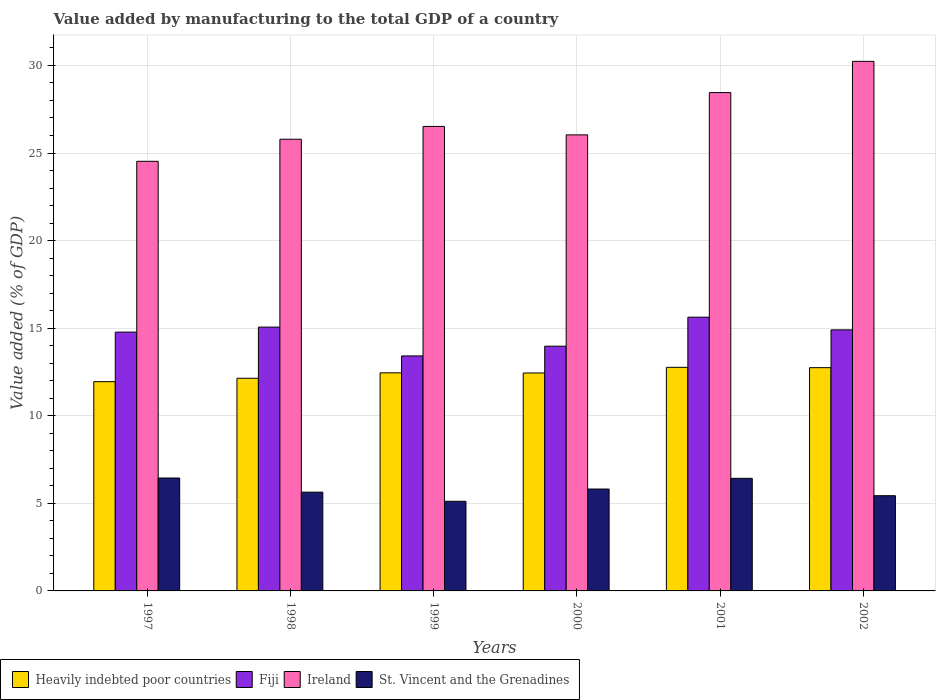How many groups of bars are there?
Keep it short and to the point. 6. Are the number of bars per tick equal to the number of legend labels?
Make the answer very short. Yes. Are the number of bars on each tick of the X-axis equal?
Provide a succinct answer. Yes. How many bars are there on the 1st tick from the right?
Make the answer very short. 4. What is the value added by manufacturing to the total GDP in Ireland in 1999?
Make the answer very short. 26.52. Across all years, what is the maximum value added by manufacturing to the total GDP in Heavily indebted poor countries?
Give a very brief answer. 12.76. Across all years, what is the minimum value added by manufacturing to the total GDP in Heavily indebted poor countries?
Your answer should be very brief. 11.95. In which year was the value added by manufacturing to the total GDP in Fiji maximum?
Your response must be concise. 2001. What is the total value added by manufacturing to the total GDP in Ireland in the graph?
Your answer should be compact. 161.55. What is the difference between the value added by manufacturing to the total GDP in Heavily indebted poor countries in 1997 and that in 1999?
Ensure brevity in your answer.  -0.5. What is the difference between the value added by manufacturing to the total GDP in Ireland in 2000 and the value added by manufacturing to the total GDP in Heavily indebted poor countries in 1998?
Make the answer very short. 13.9. What is the average value added by manufacturing to the total GDP in Heavily indebted poor countries per year?
Your answer should be very brief. 12.41. In the year 2002, what is the difference between the value added by manufacturing to the total GDP in Fiji and value added by manufacturing to the total GDP in Ireland?
Your answer should be compact. -15.33. What is the ratio of the value added by manufacturing to the total GDP in Fiji in 1998 to that in 1999?
Offer a terse response. 1.12. Is the value added by manufacturing to the total GDP in Ireland in 1997 less than that in 2001?
Ensure brevity in your answer.  Yes. What is the difference between the highest and the second highest value added by manufacturing to the total GDP in Ireland?
Provide a short and direct response. 1.78. What is the difference between the highest and the lowest value added by manufacturing to the total GDP in Heavily indebted poor countries?
Offer a terse response. 0.82. Is the sum of the value added by manufacturing to the total GDP in Ireland in 1999 and 2000 greater than the maximum value added by manufacturing to the total GDP in Heavily indebted poor countries across all years?
Ensure brevity in your answer.  Yes. What does the 1st bar from the left in 2000 represents?
Provide a succinct answer. Heavily indebted poor countries. What does the 1st bar from the right in 1999 represents?
Your answer should be compact. St. Vincent and the Grenadines. Is it the case that in every year, the sum of the value added by manufacturing to the total GDP in Heavily indebted poor countries and value added by manufacturing to the total GDP in St. Vincent and the Grenadines is greater than the value added by manufacturing to the total GDP in Ireland?
Your answer should be compact. No. Are the values on the major ticks of Y-axis written in scientific E-notation?
Offer a very short reply. No. Does the graph contain grids?
Provide a short and direct response. Yes. How are the legend labels stacked?
Offer a terse response. Horizontal. What is the title of the graph?
Make the answer very short. Value added by manufacturing to the total GDP of a country. What is the label or title of the X-axis?
Your answer should be very brief. Years. What is the label or title of the Y-axis?
Offer a very short reply. Value added (% of GDP). What is the Value added (% of GDP) of Heavily indebted poor countries in 1997?
Offer a very short reply. 11.95. What is the Value added (% of GDP) of Fiji in 1997?
Your response must be concise. 14.77. What is the Value added (% of GDP) of Ireland in 1997?
Make the answer very short. 24.53. What is the Value added (% of GDP) of St. Vincent and the Grenadines in 1997?
Offer a terse response. 6.45. What is the Value added (% of GDP) in Heavily indebted poor countries in 1998?
Offer a very short reply. 12.14. What is the Value added (% of GDP) in Fiji in 1998?
Ensure brevity in your answer.  15.06. What is the Value added (% of GDP) in Ireland in 1998?
Offer a very short reply. 25.79. What is the Value added (% of GDP) of St. Vincent and the Grenadines in 1998?
Keep it short and to the point. 5.64. What is the Value added (% of GDP) in Heavily indebted poor countries in 1999?
Offer a terse response. 12.45. What is the Value added (% of GDP) of Fiji in 1999?
Your response must be concise. 13.42. What is the Value added (% of GDP) of Ireland in 1999?
Your answer should be compact. 26.52. What is the Value added (% of GDP) in St. Vincent and the Grenadines in 1999?
Offer a terse response. 5.12. What is the Value added (% of GDP) of Heavily indebted poor countries in 2000?
Your answer should be very brief. 12.44. What is the Value added (% of GDP) of Fiji in 2000?
Offer a very short reply. 13.97. What is the Value added (% of GDP) in Ireland in 2000?
Your answer should be very brief. 26.04. What is the Value added (% of GDP) of St. Vincent and the Grenadines in 2000?
Keep it short and to the point. 5.82. What is the Value added (% of GDP) in Heavily indebted poor countries in 2001?
Provide a short and direct response. 12.76. What is the Value added (% of GDP) in Fiji in 2001?
Keep it short and to the point. 15.63. What is the Value added (% of GDP) in Ireland in 2001?
Offer a very short reply. 28.45. What is the Value added (% of GDP) in St. Vincent and the Grenadines in 2001?
Your answer should be compact. 6.43. What is the Value added (% of GDP) in Heavily indebted poor countries in 2002?
Your answer should be very brief. 12.75. What is the Value added (% of GDP) in Fiji in 2002?
Provide a succinct answer. 14.9. What is the Value added (% of GDP) in Ireland in 2002?
Your answer should be compact. 30.23. What is the Value added (% of GDP) in St. Vincent and the Grenadines in 2002?
Keep it short and to the point. 5.44. Across all years, what is the maximum Value added (% of GDP) in Heavily indebted poor countries?
Keep it short and to the point. 12.76. Across all years, what is the maximum Value added (% of GDP) in Fiji?
Your response must be concise. 15.63. Across all years, what is the maximum Value added (% of GDP) in Ireland?
Ensure brevity in your answer.  30.23. Across all years, what is the maximum Value added (% of GDP) in St. Vincent and the Grenadines?
Your response must be concise. 6.45. Across all years, what is the minimum Value added (% of GDP) in Heavily indebted poor countries?
Offer a very short reply. 11.95. Across all years, what is the minimum Value added (% of GDP) in Fiji?
Keep it short and to the point. 13.42. Across all years, what is the minimum Value added (% of GDP) of Ireland?
Ensure brevity in your answer.  24.53. Across all years, what is the minimum Value added (% of GDP) in St. Vincent and the Grenadines?
Your answer should be compact. 5.12. What is the total Value added (% of GDP) in Heavily indebted poor countries in the graph?
Keep it short and to the point. 74.49. What is the total Value added (% of GDP) of Fiji in the graph?
Your answer should be compact. 87.75. What is the total Value added (% of GDP) of Ireland in the graph?
Offer a very short reply. 161.55. What is the total Value added (% of GDP) of St. Vincent and the Grenadines in the graph?
Ensure brevity in your answer.  34.88. What is the difference between the Value added (% of GDP) of Heavily indebted poor countries in 1997 and that in 1998?
Your answer should be compact. -0.19. What is the difference between the Value added (% of GDP) in Fiji in 1997 and that in 1998?
Keep it short and to the point. -0.29. What is the difference between the Value added (% of GDP) in Ireland in 1997 and that in 1998?
Make the answer very short. -1.26. What is the difference between the Value added (% of GDP) of St. Vincent and the Grenadines in 1997 and that in 1998?
Ensure brevity in your answer.  0.81. What is the difference between the Value added (% of GDP) of Heavily indebted poor countries in 1997 and that in 1999?
Your answer should be compact. -0.5. What is the difference between the Value added (% of GDP) in Fiji in 1997 and that in 1999?
Provide a succinct answer. 1.36. What is the difference between the Value added (% of GDP) in Ireland in 1997 and that in 1999?
Offer a terse response. -1.99. What is the difference between the Value added (% of GDP) in St. Vincent and the Grenadines in 1997 and that in 1999?
Provide a short and direct response. 1.33. What is the difference between the Value added (% of GDP) of Heavily indebted poor countries in 1997 and that in 2000?
Your response must be concise. -0.49. What is the difference between the Value added (% of GDP) in Fiji in 1997 and that in 2000?
Ensure brevity in your answer.  0.8. What is the difference between the Value added (% of GDP) in Ireland in 1997 and that in 2000?
Offer a terse response. -1.51. What is the difference between the Value added (% of GDP) of St. Vincent and the Grenadines in 1997 and that in 2000?
Offer a terse response. 0.63. What is the difference between the Value added (% of GDP) of Heavily indebted poor countries in 1997 and that in 2001?
Give a very brief answer. -0.82. What is the difference between the Value added (% of GDP) in Fiji in 1997 and that in 2001?
Keep it short and to the point. -0.85. What is the difference between the Value added (% of GDP) in Ireland in 1997 and that in 2001?
Keep it short and to the point. -3.92. What is the difference between the Value added (% of GDP) in St. Vincent and the Grenadines in 1997 and that in 2001?
Your answer should be compact. 0.02. What is the difference between the Value added (% of GDP) in Heavily indebted poor countries in 1997 and that in 2002?
Provide a succinct answer. -0.8. What is the difference between the Value added (% of GDP) of Fiji in 1997 and that in 2002?
Your answer should be very brief. -0.13. What is the difference between the Value added (% of GDP) of Ireland in 1997 and that in 2002?
Make the answer very short. -5.71. What is the difference between the Value added (% of GDP) of St. Vincent and the Grenadines in 1997 and that in 2002?
Keep it short and to the point. 1.01. What is the difference between the Value added (% of GDP) in Heavily indebted poor countries in 1998 and that in 1999?
Ensure brevity in your answer.  -0.31. What is the difference between the Value added (% of GDP) of Fiji in 1998 and that in 1999?
Offer a terse response. 1.65. What is the difference between the Value added (% of GDP) in Ireland in 1998 and that in 1999?
Offer a very short reply. -0.73. What is the difference between the Value added (% of GDP) of St. Vincent and the Grenadines in 1998 and that in 1999?
Your answer should be very brief. 0.52. What is the difference between the Value added (% of GDP) of Heavily indebted poor countries in 1998 and that in 2000?
Offer a terse response. -0.3. What is the difference between the Value added (% of GDP) of Fiji in 1998 and that in 2000?
Offer a terse response. 1.09. What is the difference between the Value added (% of GDP) in Ireland in 1998 and that in 2000?
Give a very brief answer. -0.25. What is the difference between the Value added (% of GDP) of St. Vincent and the Grenadines in 1998 and that in 2000?
Your answer should be compact. -0.18. What is the difference between the Value added (% of GDP) in Heavily indebted poor countries in 1998 and that in 2001?
Provide a succinct answer. -0.62. What is the difference between the Value added (% of GDP) of Fiji in 1998 and that in 2001?
Your answer should be compact. -0.57. What is the difference between the Value added (% of GDP) of Ireland in 1998 and that in 2001?
Keep it short and to the point. -2.66. What is the difference between the Value added (% of GDP) of St. Vincent and the Grenadines in 1998 and that in 2001?
Provide a short and direct response. -0.79. What is the difference between the Value added (% of GDP) in Heavily indebted poor countries in 1998 and that in 2002?
Keep it short and to the point. -0.6. What is the difference between the Value added (% of GDP) in Fiji in 1998 and that in 2002?
Keep it short and to the point. 0.16. What is the difference between the Value added (% of GDP) of Ireland in 1998 and that in 2002?
Provide a succinct answer. -4.45. What is the difference between the Value added (% of GDP) in St. Vincent and the Grenadines in 1998 and that in 2002?
Make the answer very short. 0.2. What is the difference between the Value added (% of GDP) of Heavily indebted poor countries in 1999 and that in 2000?
Make the answer very short. 0.01. What is the difference between the Value added (% of GDP) in Fiji in 1999 and that in 2000?
Provide a succinct answer. -0.56. What is the difference between the Value added (% of GDP) in Ireland in 1999 and that in 2000?
Your answer should be compact. 0.48. What is the difference between the Value added (% of GDP) in St. Vincent and the Grenadines in 1999 and that in 2000?
Offer a terse response. -0.7. What is the difference between the Value added (% of GDP) in Heavily indebted poor countries in 1999 and that in 2001?
Provide a short and direct response. -0.31. What is the difference between the Value added (% of GDP) of Fiji in 1999 and that in 2001?
Your answer should be compact. -2.21. What is the difference between the Value added (% of GDP) of Ireland in 1999 and that in 2001?
Ensure brevity in your answer.  -1.93. What is the difference between the Value added (% of GDP) of St. Vincent and the Grenadines in 1999 and that in 2001?
Offer a terse response. -1.31. What is the difference between the Value added (% of GDP) of Heavily indebted poor countries in 1999 and that in 2002?
Your answer should be very brief. -0.29. What is the difference between the Value added (% of GDP) of Fiji in 1999 and that in 2002?
Offer a terse response. -1.49. What is the difference between the Value added (% of GDP) in Ireland in 1999 and that in 2002?
Make the answer very short. -3.72. What is the difference between the Value added (% of GDP) in St. Vincent and the Grenadines in 1999 and that in 2002?
Offer a very short reply. -0.32. What is the difference between the Value added (% of GDP) of Heavily indebted poor countries in 2000 and that in 2001?
Keep it short and to the point. -0.32. What is the difference between the Value added (% of GDP) in Fiji in 2000 and that in 2001?
Ensure brevity in your answer.  -1.66. What is the difference between the Value added (% of GDP) of Ireland in 2000 and that in 2001?
Give a very brief answer. -2.41. What is the difference between the Value added (% of GDP) in St. Vincent and the Grenadines in 2000 and that in 2001?
Ensure brevity in your answer.  -0.61. What is the difference between the Value added (% of GDP) in Heavily indebted poor countries in 2000 and that in 2002?
Provide a succinct answer. -0.3. What is the difference between the Value added (% of GDP) of Fiji in 2000 and that in 2002?
Offer a terse response. -0.93. What is the difference between the Value added (% of GDP) of Ireland in 2000 and that in 2002?
Provide a short and direct response. -4.2. What is the difference between the Value added (% of GDP) of St. Vincent and the Grenadines in 2000 and that in 2002?
Your answer should be compact. 0.38. What is the difference between the Value added (% of GDP) in Heavily indebted poor countries in 2001 and that in 2002?
Your response must be concise. 0.02. What is the difference between the Value added (% of GDP) in Fiji in 2001 and that in 2002?
Keep it short and to the point. 0.72. What is the difference between the Value added (% of GDP) in Ireland in 2001 and that in 2002?
Give a very brief answer. -1.78. What is the difference between the Value added (% of GDP) of Heavily indebted poor countries in 1997 and the Value added (% of GDP) of Fiji in 1998?
Make the answer very short. -3.12. What is the difference between the Value added (% of GDP) of Heavily indebted poor countries in 1997 and the Value added (% of GDP) of Ireland in 1998?
Keep it short and to the point. -13.84. What is the difference between the Value added (% of GDP) in Heavily indebted poor countries in 1997 and the Value added (% of GDP) in St. Vincent and the Grenadines in 1998?
Provide a succinct answer. 6.31. What is the difference between the Value added (% of GDP) of Fiji in 1997 and the Value added (% of GDP) of Ireland in 1998?
Provide a succinct answer. -11.01. What is the difference between the Value added (% of GDP) in Fiji in 1997 and the Value added (% of GDP) in St. Vincent and the Grenadines in 1998?
Make the answer very short. 9.14. What is the difference between the Value added (% of GDP) in Ireland in 1997 and the Value added (% of GDP) in St. Vincent and the Grenadines in 1998?
Ensure brevity in your answer.  18.89. What is the difference between the Value added (% of GDP) of Heavily indebted poor countries in 1997 and the Value added (% of GDP) of Fiji in 1999?
Provide a succinct answer. -1.47. What is the difference between the Value added (% of GDP) in Heavily indebted poor countries in 1997 and the Value added (% of GDP) in Ireland in 1999?
Provide a succinct answer. -14.57. What is the difference between the Value added (% of GDP) in Heavily indebted poor countries in 1997 and the Value added (% of GDP) in St. Vincent and the Grenadines in 1999?
Keep it short and to the point. 6.83. What is the difference between the Value added (% of GDP) in Fiji in 1997 and the Value added (% of GDP) in Ireland in 1999?
Your answer should be compact. -11.74. What is the difference between the Value added (% of GDP) in Fiji in 1997 and the Value added (% of GDP) in St. Vincent and the Grenadines in 1999?
Provide a succinct answer. 9.66. What is the difference between the Value added (% of GDP) in Ireland in 1997 and the Value added (% of GDP) in St. Vincent and the Grenadines in 1999?
Provide a short and direct response. 19.41. What is the difference between the Value added (% of GDP) of Heavily indebted poor countries in 1997 and the Value added (% of GDP) of Fiji in 2000?
Keep it short and to the point. -2.02. What is the difference between the Value added (% of GDP) in Heavily indebted poor countries in 1997 and the Value added (% of GDP) in Ireland in 2000?
Provide a short and direct response. -14.09. What is the difference between the Value added (% of GDP) in Heavily indebted poor countries in 1997 and the Value added (% of GDP) in St. Vincent and the Grenadines in 2000?
Offer a terse response. 6.13. What is the difference between the Value added (% of GDP) of Fiji in 1997 and the Value added (% of GDP) of Ireland in 2000?
Offer a very short reply. -11.26. What is the difference between the Value added (% of GDP) of Fiji in 1997 and the Value added (% of GDP) of St. Vincent and the Grenadines in 2000?
Provide a succinct answer. 8.96. What is the difference between the Value added (% of GDP) in Ireland in 1997 and the Value added (% of GDP) in St. Vincent and the Grenadines in 2000?
Your answer should be very brief. 18.71. What is the difference between the Value added (% of GDP) of Heavily indebted poor countries in 1997 and the Value added (% of GDP) of Fiji in 2001?
Provide a short and direct response. -3.68. What is the difference between the Value added (% of GDP) of Heavily indebted poor countries in 1997 and the Value added (% of GDP) of Ireland in 2001?
Your response must be concise. -16.5. What is the difference between the Value added (% of GDP) in Heavily indebted poor countries in 1997 and the Value added (% of GDP) in St. Vincent and the Grenadines in 2001?
Provide a succinct answer. 5.52. What is the difference between the Value added (% of GDP) in Fiji in 1997 and the Value added (% of GDP) in Ireland in 2001?
Ensure brevity in your answer.  -13.67. What is the difference between the Value added (% of GDP) of Fiji in 1997 and the Value added (% of GDP) of St. Vincent and the Grenadines in 2001?
Your answer should be very brief. 8.35. What is the difference between the Value added (% of GDP) in Ireland in 1997 and the Value added (% of GDP) in St. Vincent and the Grenadines in 2001?
Offer a terse response. 18.1. What is the difference between the Value added (% of GDP) in Heavily indebted poor countries in 1997 and the Value added (% of GDP) in Fiji in 2002?
Provide a short and direct response. -2.96. What is the difference between the Value added (% of GDP) of Heavily indebted poor countries in 1997 and the Value added (% of GDP) of Ireland in 2002?
Provide a short and direct response. -18.29. What is the difference between the Value added (% of GDP) of Heavily indebted poor countries in 1997 and the Value added (% of GDP) of St. Vincent and the Grenadines in 2002?
Your response must be concise. 6.51. What is the difference between the Value added (% of GDP) in Fiji in 1997 and the Value added (% of GDP) in Ireland in 2002?
Provide a succinct answer. -15.46. What is the difference between the Value added (% of GDP) in Fiji in 1997 and the Value added (% of GDP) in St. Vincent and the Grenadines in 2002?
Keep it short and to the point. 9.34. What is the difference between the Value added (% of GDP) of Ireland in 1997 and the Value added (% of GDP) of St. Vincent and the Grenadines in 2002?
Make the answer very short. 19.09. What is the difference between the Value added (% of GDP) of Heavily indebted poor countries in 1998 and the Value added (% of GDP) of Fiji in 1999?
Offer a very short reply. -1.27. What is the difference between the Value added (% of GDP) of Heavily indebted poor countries in 1998 and the Value added (% of GDP) of Ireland in 1999?
Give a very brief answer. -14.38. What is the difference between the Value added (% of GDP) in Heavily indebted poor countries in 1998 and the Value added (% of GDP) in St. Vincent and the Grenadines in 1999?
Your answer should be compact. 7.02. What is the difference between the Value added (% of GDP) of Fiji in 1998 and the Value added (% of GDP) of Ireland in 1999?
Provide a short and direct response. -11.46. What is the difference between the Value added (% of GDP) of Fiji in 1998 and the Value added (% of GDP) of St. Vincent and the Grenadines in 1999?
Provide a short and direct response. 9.94. What is the difference between the Value added (% of GDP) in Ireland in 1998 and the Value added (% of GDP) in St. Vincent and the Grenadines in 1999?
Keep it short and to the point. 20.67. What is the difference between the Value added (% of GDP) in Heavily indebted poor countries in 1998 and the Value added (% of GDP) in Fiji in 2000?
Provide a succinct answer. -1.83. What is the difference between the Value added (% of GDP) in Heavily indebted poor countries in 1998 and the Value added (% of GDP) in Ireland in 2000?
Provide a short and direct response. -13.9. What is the difference between the Value added (% of GDP) of Heavily indebted poor countries in 1998 and the Value added (% of GDP) of St. Vincent and the Grenadines in 2000?
Your answer should be compact. 6.32. What is the difference between the Value added (% of GDP) in Fiji in 1998 and the Value added (% of GDP) in Ireland in 2000?
Offer a very short reply. -10.97. What is the difference between the Value added (% of GDP) of Fiji in 1998 and the Value added (% of GDP) of St. Vincent and the Grenadines in 2000?
Make the answer very short. 9.24. What is the difference between the Value added (% of GDP) of Ireland in 1998 and the Value added (% of GDP) of St. Vincent and the Grenadines in 2000?
Offer a terse response. 19.97. What is the difference between the Value added (% of GDP) of Heavily indebted poor countries in 1998 and the Value added (% of GDP) of Fiji in 2001?
Provide a short and direct response. -3.49. What is the difference between the Value added (% of GDP) in Heavily indebted poor countries in 1998 and the Value added (% of GDP) in Ireland in 2001?
Keep it short and to the point. -16.31. What is the difference between the Value added (% of GDP) of Heavily indebted poor countries in 1998 and the Value added (% of GDP) of St. Vincent and the Grenadines in 2001?
Your response must be concise. 5.71. What is the difference between the Value added (% of GDP) in Fiji in 1998 and the Value added (% of GDP) in Ireland in 2001?
Give a very brief answer. -13.39. What is the difference between the Value added (% of GDP) in Fiji in 1998 and the Value added (% of GDP) in St. Vincent and the Grenadines in 2001?
Your answer should be compact. 8.63. What is the difference between the Value added (% of GDP) in Ireland in 1998 and the Value added (% of GDP) in St. Vincent and the Grenadines in 2001?
Offer a very short reply. 19.36. What is the difference between the Value added (% of GDP) of Heavily indebted poor countries in 1998 and the Value added (% of GDP) of Fiji in 2002?
Offer a very short reply. -2.76. What is the difference between the Value added (% of GDP) of Heavily indebted poor countries in 1998 and the Value added (% of GDP) of Ireland in 2002?
Your answer should be very brief. -18.09. What is the difference between the Value added (% of GDP) in Heavily indebted poor countries in 1998 and the Value added (% of GDP) in St. Vincent and the Grenadines in 2002?
Ensure brevity in your answer.  6.7. What is the difference between the Value added (% of GDP) in Fiji in 1998 and the Value added (% of GDP) in Ireland in 2002?
Your answer should be very brief. -15.17. What is the difference between the Value added (% of GDP) in Fiji in 1998 and the Value added (% of GDP) in St. Vincent and the Grenadines in 2002?
Your response must be concise. 9.63. What is the difference between the Value added (% of GDP) of Ireland in 1998 and the Value added (% of GDP) of St. Vincent and the Grenadines in 2002?
Your answer should be very brief. 20.35. What is the difference between the Value added (% of GDP) in Heavily indebted poor countries in 1999 and the Value added (% of GDP) in Fiji in 2000?
Your answer should be compact. -1.52. What is the difference between the Value added (% of GDP) of Heavily indebted poor countries in 1999 and the Value added (% of GDP) of Ireland in 2000?
Your answer should be very brief. -13.59. What is the difference between the Value added (% of GDP) of Heavily indebted poor countries in 1999 and the Value added (% of GDP) of St. Vincent and the Grenadines in 2000?
Keep it short and to the point. 6.63. What is the difference between the Value added (% of GDP) in Fiji in 1999 and the Value added (% of GDP) in Ireland in 2000?
Provide a succinct answer. -12.62. What is the difference between the Value added (% of GDP) of Fiji in 1999 and the Value added (% of GDP) of St. Vincent and the Grenadines in 2000?
Provide a short and direct response. 7.6. What is the difference between the Value added (% of GDP) of Ireland in 1999 and the Value added (% of GDP) of St. Vincent and the Grenadines in 2000?
Your answer should be very brief. 20.7. What is the difference between the Value added (% of GDP) in Heavily indebted poor countries in 1999 and the Value added (% of GDP) in Fiji in 2001?
Your answer should be very brief. -3.18. What is the difference between the Value added (% of GDP) in Heavily indebted poor countries in 1999 and the Value added (% of GDP) in Ireland in 2001?
Make the answer very short. -16. What is the difference between the Value added (% of GDP) in Heavily indebted poor countries in 1999 and the Value added (% of GDP) in St. Vincent and the Grenadines in 2001?
Make the answer very short. 6.02. What is the difference between the Value added (% of GDP) in Fiji in 1999 and the Value added (% of GDP) in Ireland in 2001?
Your answer should be compact. -15.03. What is the difference between the Value added (% of GDP) in Fiji in 1999 and the Value added (% of GDP) in St. Vincent and the Grenadines in 2001?
Keep it short and to the point. 6.99. What is the difference between the Value added (% of GDP) of Ireland in 1999 and the Value added (% of GDP) of St. Vincent and the Grenadines in 2001?
Your answer should be compact. 20.09. What is the difference between the Value added (% of GDP) in Heavily indebted poor countries in 1999 and the Value added (% of GDP) in Fiji in 2002?
Offer a terse response. -2.45. What is the difference between the Value added (% of GDP) of Heavily indebted poor countries in 1999 and the Value added (% of GDP) of Ireland in 2002?
Your response must be concise. -17.78. What is the difference between the Value added (% of GDP) in Heavily indebted poor countries in 1999 and the Value added (% of GDP) in St. Vincent and the Grenadines in 2002?
Keep it short and to the point. 7.01. What is the difference between the Value added (% of GDP) in Fiji in 1999 and the Value added (% of GDP) in Ireland in 2002?
Give a very brief answer. -16.82. What is the difference between the Value added (% of GDP) in Fiji in 1999 and the Value added (% of GDP) in St. Vincent and the Grenadines in 2002?
Give a very brief answer. 7.98. What is the difference between the Value added (% of GDP) in Ireland in 1999 and the Value added (% of GDP) in St. Vincent and the Grenadines in 2002?
Offer a terse response. 21.08. What is the difference between the Value added (% of GDP) of Heavily indebted poor countries in 2000 and the Value added (% of GDP) of Fiji in 2001?
Your answer should be very brief. -3.19. What is the difference between the Value added (% of GDP) of Heavily indebted poor countries in 2000 and the Value added (% of GDP) of Ireland in 2001?
Your response must be concise. -16.01. What is the difference between the Value added (% of GDP) of Heavily indebted poor countries in 2000 and the Value added (% of GDP) of St. Vincent and the Grenadines in 2001?
Offer a very short reply. 6.01. What is the difference between the Value added (% of GDP) of Fiji in 2000 and the Value added (% of GDP) of Ireland in 2001?
Ensure brevity in your answer.  -14.48. What is the difference between the Value added (% of GDP) in Fiji in 2000 and the Value added (% of GDP) in St. Vincent and the Grenadines in 2001?
Keep it short and to the point. 7.54. What is the difference between the Value added (% of GDP) of Ireland in 2000 and the Value added (% of GDP) of St. Vincent and the Grenadines in 2001?
Give a very brief answer. 19.61. What is the difference between the Value added (% of GDP) in Heavily indebted poor countries in 2000 and the Value added (% of GDP) in Fiji in 2002?
Give a very brief answer. -2.46. What is the difference between the Value added (% of GDP) in Heavily indebted poor countries in 2000 and the Value added (% of GDP) in Ireland in 2002?
Your response must be concise. -17.79. What is the difference between the Value added (% of GDP) in Heavily indebted poor countries in 2000 and the Value added (% of GDP) in St. Vincent and the Grenadines in 2002?
Keep it short and to the point. 7.01. What is the difference between the Value added (% of GDP) in Fiji in 2000 and the Value added (% of GDP) in Ireland in 2002?
Make the answer very short. -16.26. What is the difference between the Value added (% of GDP) in Fiji in 2000 and the Value added (% of GDP) in St. Vincent and the Grenadines in 2002?
Make the answer very short. 8.54. What is the difference between the Value added (% of GDP) of Ireland in 2000 and the Value added (% of GDP) of St. Vincent and the Grenadines in 2002?
Your response must be concise. 20.6. What is the difference between the Value added (% of GDP) in Heavily indebted poor countries in 2001 and the Value added (% of GDP) in Fiji in 2002?
Keep it short and to the point. -2.14. What is the difference between the Value added (% of GDP) in Heavily indebted poor countries in 2001 and the Value added (% of GDP) in Ireland in 2002?
Offer a terse response. -17.47. What is the difference between the Value added (% of GDP) of Heavily indebted poor countries in 2001 and the Value added (% of GDP) of St. Vincent and the Grenadines in 2002?
Offer a terse response. 7.33. What is the difference between the Value added (% of GDP) in Fiji in 2001 and the Value added (% of GDP) in Ireland in 2002?
Your response must be concise. -14.61. What is the difference between the Value added (% of GDP) of Fiji in 2001 and the Value added (% of GDP) of St. Vincent and the Grenadines in 2002?
Your answer should be very brief. 10.19. What is the difference between the Value added (% of GDP) of Ireland in 2001 and the Value added (% of GDP) of St. Vincent and the Grenadines in 2002?
Offer a very short reply. 23.01. What is the average Value added (% of GDP) of Heavily indebted poor countries per year?
Ensure brevity in your answer.  12.41. What is the average Value added (% of GDP) of Fiji per year?
Make the answer very short. 14.63. What is the average Value added (% of GDP) of Ireland per year?
Offer a terse response. 26.92. What is the average Value added (% of GDP) of St. Vincent and the Grenadines per year?
Offer a terse response. 5.81. In the year 1997, what is the difference between the Value added (% of GDP) in Heavily indebted poor countries and Value added (% of GDP) in Fiji?
Give a very brief answer. -2.83. In the year 1997, what is the difference between the Value added (% of GDP) of Heavily indebted poor countries and Value added (% of GDP) of Ireland?
Ensure brevity in your answer.  -12.58. In the year 1997, what is the difference between the Value added (% of GDP) in Heavily indebted poor countries and Value added (% of GDP) in St. Vincent and the Grenadines?
Keep it short and to the point. 5.5. In the year 1997, what is the difference between the Value added (% of GDP) of Fiji and Value added (% of GDP) of Ireland?
Offer a very short reply. -9.75. In the year 1997, what is the difference between the Value added (% of GDP) of Fiji and Value added (% of GDP) of St. Vincent and the Grenadines?
Provide a short and direct response. 8.33. In the year 1997, what is the difference between the Value added (% of GDP) in Ireland and Value added (% of GDP) in St. Vincent and the Grenadines?
Ensure brevity in your answer.  18.08. In the year 1998, what is the difference between the Value added (% of GDP) in Heavily indebted poor countries and Value added (% of GDP) in Fiji?
Provide a succinct answer. -2.92. In the year 1998, what is the difference between the Value added (% of GDP) in Heavily indebted poor countries and Value added (% of GDP) in Ireland?
Offer a terse response. -13.65. In the year 1998, what is the difference between the Value added (% of GDP) in Heavily indebted poor countries and Value added (% of GDP) in St. Vincent and the Grenadines?
Keep it short and to the point. 6.5. In the year 1998, what is the difference between the Value added (% of GDP) in Fiji and Value added (% of GDP) in Ireland?
Provide a short and direct response. -10.73. In the year 1998, what is the difference between the Value added (% of GDP) in Fiji and Value added (% of GDP) in St. Vincent and the Grenadines?
Provide a succinct answer. 9.42. In the year 1998, what is the difference between the Value added (% of GDP) in Ireland and Value added (% of GDP) in St. Vincent and the Grenadines?
Your response must be concise. 20.15. In the year 1999, what is the difference between the Value added (% of GDP) in Heavily indebted poor countries and Value added (% of GDP) in Fiji?
Offer a terse response. -0.96. In the year 1999, what is the difference between the Value added (% of GDP) of Heavily indebted poor countries and Value added (% of GDP) of Ireland?
Give a very brief answer. -14.07. In the year 1999, what is the difference between the Value added (% of GDP) in Heavily indebted poor countries and Value added (% of GDP) in St. Vincent and the Grenadines?
Provide a short and direct response. 7.33. In the year 1999, what is the difference between the Value added (% of GDP) of Fiji and Value added (% of GDP) of Ireland?
Provide a succinct answer. -13.1. In the year 1999, what is the difference between the Value added (% of GDP) in Fiji and Value added (% of GDP) in St. Vincent and the Grenadines?
Ensure brevity in your answer.  8.3. In the year 1999, what is the difference between the Value added (% of GDP) in Ireland and Value added (% of GDP) in St. Vincent and the Grenadines?
Provide a short and direct response. 21.4. In the year 2000, what is the difference between the Value added (% of GDP) in Heavily indebted poor countries and Value added (% of GDP) in Fiji?
Keep it short and to the point. -1.53. In the year 2000, what is the difference between the Value added (% of GDP) of Heavily indebted poor countries and Value added (% of GDP) of Ireland?
Your answer should be compact. -13.59. In the year 2000, what is the difference between the Value added (% of GDP) of Heavily indebted poor countries and Value added (% of GDP) of St. Vincent and the Grenadines?
Make the answer very short. 6.62. In the year 2000, what is the difference between the Value added (% of GDP) of Fiji and Value added (% of GDP) of Ireland?
Provide a succinct answer. -12.06. In the year 2000, what is the difference between the Value added (% of GDP) of Fiji and Value added (% of GDP) of St. Vincent and the Grenadines?
Keep it short and to the point. 8.15. In the year 2000, what is the difference between the Value added (% of GDP) in Ireland and Value added (% of GDP) in St. Vincent and the Grenadines?
Provide a short and direct response. 20.22. In the year 2001, what is the difference between the Value added (% of GDP) of Heavily indebted poor countries and Value added (% of GDP) of Fiji?
Provide a short and direct response. -2.86. In the year 2001, what is the difference between the Value added (% of GDP) in Heavily indebted poor countries and Value added (% of GDP) in Ireland?
Your answer should be very brief. -15.68. In the year 2001, what is the difference between the Value added (% of GDP) in Heavily indebted poor countries and Value added (% of GDP) in St. Vincent and the Grenadines?
Offer a terse response. 6.34. In the year 2001, what is the difference between the Value added (% of GDP) of Fiji and Value added (% of GDP) of Ireland?
Make the answer very short. -12.82. In the year 2001, what is the difference between the Value added (% of GDP) of Fiji and Value added (% of GDP) of St. Vincent and the Grenadines?
Your response must be concise. 9.2. In the year 2001, what is the difference between the Value added (% of GDP) in Ireland and Value added (% of GDP) in St. Vincent and the Grenadines?
Provide a short and direct response. 22.02. In the year 2002, what is the difference between the Value added (% of GDP) in Heavily indebted poor countries and Value added (% of GDP) in Fiji?
Offer a very short reply. -2.16. In the year 2002, what is the difference between the Value added (% of GDP) in Heavily indebted poor countries and Value added (% of GDP) in Ireland?
Your answer should be very brief. -17.49. In the year 2002, what is the difference between the Value added (% of GDP) in Heavily indebted poor countries and Value added (% of GDP) in St. Vincent and the Grenadines?
Your answer should be compact. 7.31. In the year 2002, what is the difference between the Value added (% of GDP) of Fiji and Value added (% of GDP) of Ireland?
Ensure brevity in your answer.  -15.33. In the year 2002, what is the difference between the Value added (% of GDP) in Fiji and Value added (% of GDP) in St. Vincent and the Grenadines?
Offer a terse response. 9.47. In the year 2002, what is the difference between the Value added (% of GDP) of Ireland and Value added (% of GDP) of St. Vincent and the Grenadines?
Your answer should be compact. 24.8. What is the ratio of the Value added (% of GDP) in Fiji in 1997 to that in 1998?
Offer a terse response. 0.98. What is the ratio of the Value added (% of GDP) in Ireland in 1997 to that in 1998?
Keep it short and to the point. 0.95. What is the ratio of the Value added (% of GDP) of St. Vincent and the Grenadines in 1997 to that in 1998?
Ensure brevity in your answer.  1.14. What is the ratio of the Value added (% of GDP) in Heavily indebted poor countries in 1997 to that in 1999?
Provide a short and direct response. 0.96. What is the ratio of the Value added (% of GDP) in Fiji in 1997 to that in 1999?
Offer a terse response. 1.1. What is the ratio of the Value added (% of GDP) in Ireland in 1997 to that in 1999?
Keep it short and to the point. 0.92. What is the ratio of the Value added (% of GDP) of St. Vincent and the Grenadines in 1997 to that in 1999?
Provide a short and direct response. 1.26. What is the ratio of the Value added (% of GDP) in Heavily indebted poor countries in 1997 to that in 2000?
Your response must be concise. 0.96. What is the ratio of the Value added (% of GDP) of Fiji in 1997 to that in 2000?
Your answer should be very brief. 1.06. What is the ratio of the Value added (% of GDP) of Ireland in 1997 to that in 2000?
Your answer should be very brief. 0.94. What is the ratio of the Value added (% of GDP) in St. Vincent and the Grenadines in 1997 to that in 2000?
Ensure brevity in your answer.  1.11. What is the ratio of the Value added (% of GDP) of Heavily indebted poor countries in 1997 to that in 2001?
Your answer should be compact. 0.94. What is the ratio of the Value added (% of GDP) in Fiji in 1997 to that in 2001?
Your response must be concise. 0.95. What is the ratio of the Value added (% of GDP) in Ireland in 1997 to that in 2001?
Your response must be concise. 0.86. What is the ratio of the Value added (% of GDP) in St. Vincent and the Grenadines in 1997 to that in 2001?
Offer a very short reply. 1. What is the ratio of the Value added (% of GDP) in Heavily indebted poor countries in 1997 to that in 2002?
Offer a very short reply. 0.94. What is the ratio of the Value added (% of GDP) of Ireland in 1997 to that in 2002?
Provide a short and direct response. 0.81. What is the ratio of the Value added (% of GDP) in St. Vincent and the Grenadines in 1997 to that in 2002?
Your answer should be compact. 1.19. What is the ratio of the Value added (% of GDP) in Heavily indebted poor countries in 1998 to that in 1999?
Offer a terse response. 0.98. What is the ratio of the Value added (% of GDP) of Fiji in 1998 to that in 1999?
Give a very brief answer. 1.12. What is the ratio of the Value added (% of GDP) of Ireland in 1998 to that in 1999?
Provide a succinct answer. 0.97. What is the ratio of the Value added (% of GDP) of St. Vincent and the Grenadines in 1998 to that in 1999?
Provide a succinct answer. 1.1. What is the ratio of the Value added (% of GDP) of Heavily indebted poor countries in 1998 to that in 2000?
Offer a very short reply. 0.98. What is the ratio of the Value added (% of GDP) in Fiji in 1998 to that in 2000?
Offer a terse response. 1.08. What is the ratio of the Value added (% of GDP) in St. Vincent and the Grenadines in 1998 to that in 2000?
Make the answer very short. 0.97. What is the ratio of the Value added (% of GDP) in Heavily indebted poor countries in 1998 to that in 2001?
Provide a succinct answer. 0.95. What is the ratio of the Value added (% of GDP) of Fiji in 1998 to that in 2001?
Offer a very short reply. 0.96. What is the ratio of the Value added (% of GDP) in Ireland in 1998 to that in 2001?
Your response must be concise. 0.91. What is the ratio of the Value added (% of GDP) of St. Vincent and the Grenadines in 1998 to that in 2001?
Provide a succinct answer. 0.88. What is the ratio of the Value added (% of GDP) in Heavily indebted poor countries in 1998 to that in 2002?
Offer a terse response. 0.95. What is the ratio of the Value added (% of GDP) of Fiji in 1998 to that in 2002?
Offer a very short reply. 1.01. What is the ratio of the Value added (% of GDP) in Ireland in 1998 to that in 2002?
Your response must be concise. 0.85. What is the ratio of the Value added (% of GDP) in St. Vincent and the Grenadines in 1998 to that in 2002?
Your response must be concise. 1.04. What is the ratio of the Value added (% of GDP) of Heavily indebted poor countries in 1999 to that in 2000?
Offer a very short reply. 1. What is the ratio of the Value added (% of GDP) of Fiji in 1999 to that in 2000?
Your response must be concise. 0.96. What is the ratio of the Value added (% of GDP) of Ireland in 1999 to that in 2000?
Offer a very short reply. 1.02. What is the ratio of the Value added (% of GDP) of St. Vincent and the Grenadines in 1999 to that in 2000?
Offer a terse response. 0.88. What is the ratio of the Value added (% of GDP) in Heavily indebted poor countries in 1999 to that in 2001?
Ensure brevity in your answer.  0.98. What is the ratio of the Value added (% of GDP) in Fiji in 1999 to that in 2001?
Your answer should be compact. 0.86. What is the ratio of the Value added (% of GDP) of Ireland in 1999 to that in 2001?
Offer a terse response. 0.93. What is the ratio of the Value added (% of GDP) in St. Vincent and the Grenadines in 1999 to that in 2001?
Offer a terse response. 0.8. What is the ratio of the Value added (% of GDP) in Heavily indebted poor countries in 1999 to that in 2002?
Your response must be concise. 0.98. What is the ratio of the Value added (% of GDP) of Fiji in 1999 to that in 2002?
Your response must be concise. 0.9. What is the ratio of the Value added (% of GDP) in Ireland in 1999 to that in 2002?
Offer a very short reply. 0.88. What is the ratio of the Value added (% of GDP) of St. Vincent and the Grenadines in 1999 to that in 2002?
Keep it short and to the point. 0.94. What is the ratio of the Value added (% of GDP) in Heavily indebted poor countries in 2000 to that in 2001?
Give a very brief answer. 0.97. What is the ratio of the Value added (% of GDP) of Fiji in 2000 to that in 2001?
Give a very brief answer. 0.89. What is the ratio of the Value added (% of GDP) in Ireland in 2000 to that in 2001?
Provide a short and direct response. 0.92. What is the ratio of the Value added (% of GDP) in St. Vincent and the Grenadines in 2000 to that in 2001?
Offer a terse response. 0.91. What is the ratio of the Value added (% of GDP) in Heavily indebted poor countries in 2000 to that in 2002?
Ensure brevity in your answer.  0.98. What is the ratio of the Value added (% of GDP) in Ireland in 2000 to that in 2002?
Your response must be concise. 0.86. What is the ratio of the Value added (% of GDP) of St. Vincent and the Grenadines in 2000 to that in 2002?
Provide a succinct answer. 1.07. What is the ratio of the Value added (% of GDP) of Fiji in 2001 to that in 2002?
Make the answer very short. 1.05. What is the ratio of the Value added (% of GDP) in Ireland in 2001 to that in 2002?
Your response must be concise. 0.94. What is the ratio of the Value added (% of GDP) of St. Vincent and the Grenadines in 2001 to that in 2002?
Keep it short and to the point. 1.18. What is the difference between the highest and the second highest Value added (% of GDP) of Heavily indebted poor countries?
Your answer should be very brief. 0.02. What is the difference between the highest and the second highest Value added (% of GDP) of Fiji?
Provide a succinct answer. 0.57. What is the difference between the highest and the second highest Value added (% of GDP) of Ireland?
Provide a succinct answer. 1.78. What is the difference between the highest and the second highest Value added (% of GDP) of St. Vincent and the Grenadines?
Make the answer very short. 0.02. What is the difference between the highest and the lowest Value added (% of GDP) in Heavily indebted poor countries?
Give a very brief answer. 0.82. What is the difference between the highest and the lowest Value added (% of GDP) of Fiji?
Offer a very short reply. 2.21. What is the difference between the highest and the lowest Value added (% of GDP) of Ireland?
Give a very brief answer. 5.71. What is the difference between the highest and the lowest Value added (% of GDP) in St. Vincent and the Grenadines?
Provide a succinct answer. 1.33. 